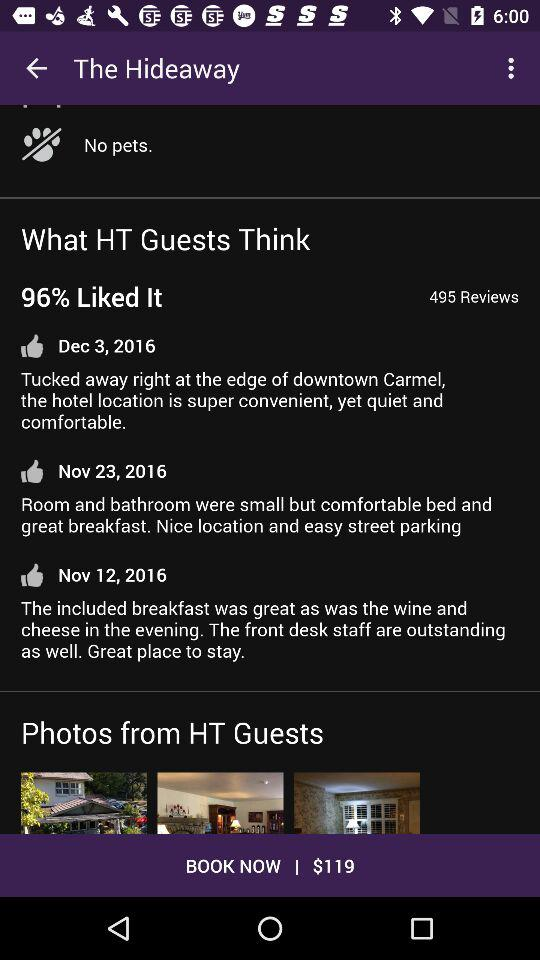What are the charges for booking? The booking charges are $119. 